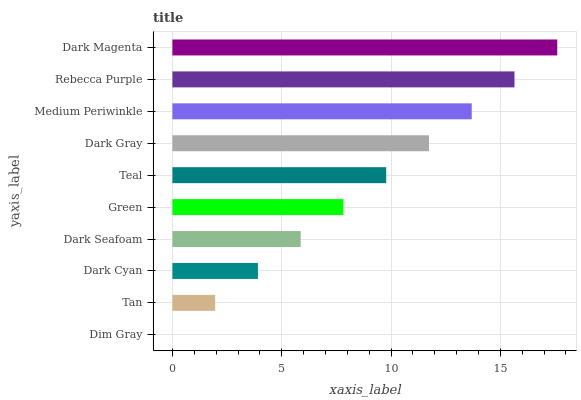Is Dim Gray the minimum?
Answer yes or no. Yes. Is Dark Magenta the maximum?
Answer yes or no. Yes. Is Tan the minimum?
Answer yes or no. No. Is Tan the maximum?
Answer yes or no. No. Is Tan greater than Dim Gray?
Answer yes or no. Yes. Is Dim Gray less than Tan?
Answer yes or no. Yes. Is Dim Gray greater than Tan?
Answer yes or no. No. Is Tan less than Dim Gray?
Answer yes or no. No. Is Teal the high median?
Answer yes or no. Yes. Is Green the low median?
Answer yes or no. Yes. Is Tan the high median?
Answer yes or no. No. Is Tan the low median?
Answer yes or no. No. 